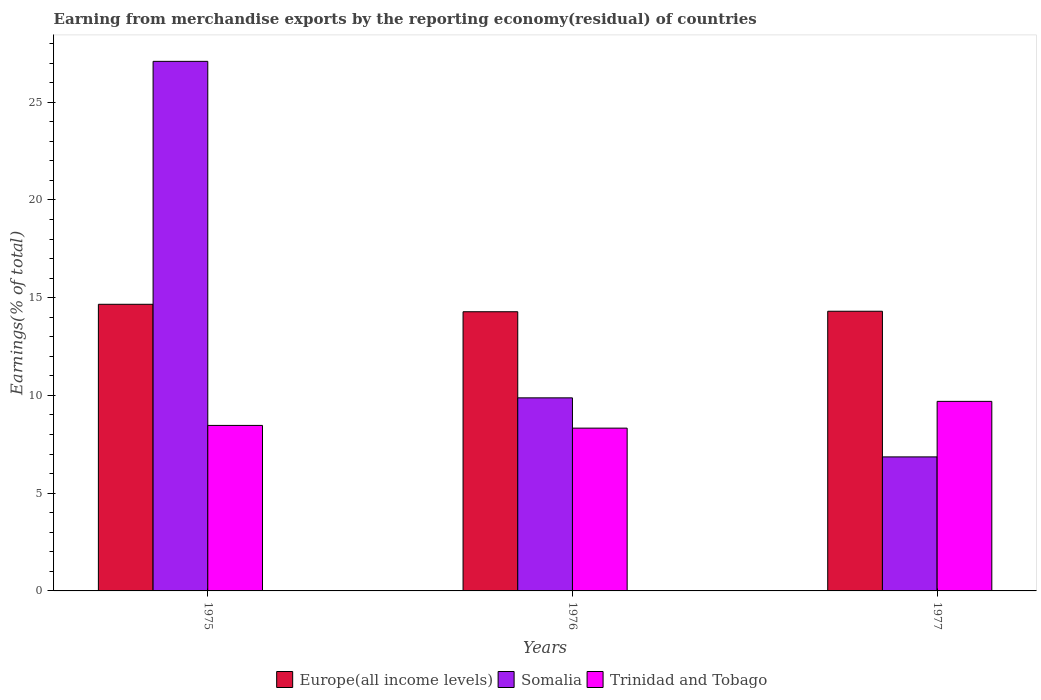How many groups of bars are there?
Provide a short and direct response. 3. Are the number of bars per tick equal to the number of legend labels?
Provide a short and direct response. Yes. Are the number of bars on each tick of the X-axis equal?
Keep it short and to the point. Yes. What is the label of the 2nd group of bars from the left?
Offer a terse response. 1976. What is the percentage of amount earned from merchandise exports in Europe(all income levels) in 1977?
Offer a very short reply. 14.31. Across all years, what is the maximum percentage of amount earned from merchandise exports in Somalia?
Give a very brief answer. 27.09. Across all years, what is the minimum percentage of amount earned from merchandise exports in Somalia?
Make the answer very short. 6.86. In which year was the percentage of amount earned from merchandise exports in Europe(all income levels) maximum?
Make the answer very short. 1975. In which year was the percentage of amount earned from merchandise exports in Trinidad and Tobago minimum?
Provide a short and direct response. 1976. What is the total percentage of amount earned from merchandise exports in Trinidad and Tobago in the graph?
Give a very brief answer. 26.49. What is the difference between the percentage of amount earned from merchandise exports in Somalia in 1975 and that in 1977?
Keep it short and to the point. 20.24. What is the difference between the percentage of amount earned from merchandise exports in Europe(all income levels) in 1977 and the percentage of amount earned from merchandise exports in Trinidad and Tobago in 1976?
Keep it short and to the point. 5.98. What is the average percentage of amount earned from merchandise exports in Trinidad and Tobago per year?
Give a very brief answer. 8.83. In the year 1976, what is the difference between the percentage of amount earned from merchandise exports in Europe(all income levels) and percentage of amount earned from merchandise exports in Somalia?
Give a very brief answer. 4.4. In how many years, is the percentage of amount earned from merchandise exports in Trinidad and Tobago greater than 24 %?
Offer a very short reply. 0. What is the ratio of the percentage of amount earned from merchandise exports in Somalia in 1976 to that in 1977?
Your answer should be very brief. 1.44. Is the percentage of amount earned from merchandise exports in Europe(all income levels) in 1975 less than that in 1976?
Offer a terse response. No. What is the difference between the highest and the second highest percentage of amount earned from merchandise exports in Trinidad and Tobago?
Offer a terse response. 1.23. What is the difference between the highest and the lowest percentage of amount earned from merchandise exports in Somalia?
Give a very brief answer. 20.24. What does the 3rd bar from the left in 1977 represents?
Provide a succinct answer. Trinidad and Tobago. What does the 1st bar from the right in 1975 represents?
Your response must be concise. Trinidad and Tobago. How many bars are there?
Make the answer very short. 9. Are the values on the major ticks of Y-axis written in scientific E-notation?
Your response must be concise. No. How many legend labels are there?
Make the answer very short. 3. How are the legend labels stacked?
Your answer should be very brief. Horizontal. What is the title of the graph?
Give a very brief answer. Earning from merchandise exports by the reporting economy(residual) of countries. What is the label or title of the Y-axis?
Give a very brief answer. Earnings(% of total). What is the Earnings(% of total) of Europe(all income levels) in 1975?
Your answer should be very brief. 14.66. What is the Earnings(% of total) of Somalia in 1975?
Your answer should be compact. 27.09. What is the Earnings(% of total) of Trinidad and Tobago in 1975?
Your answer should be compact. 8.47. What is the Earnings(% of total) of Europe(all income levels) in 1976?
Your response must be concise. 14.28. What is the Earnings(% of total) of Somalia in 1976?
Offer a very short reply. 9.88. What is the Earnings(% of total) in Trinidad and Tobago in 1976?
Keep it short and to the point. 8.33. What is the Earnings(% of total) in Europe(all income levels) in 1977?
Your answer should be very brief. 14.31. What is the Earnings(% of total) in Somalia in 1977?
Your response must be concise. 6.86. What is the Earnings(% of total) of Trinidad and Tobago in 1977?
Offer a terse response. 9.7. Across all years, what is the maximum Earnings(% of total) of Europe(all income levels)?
Ensure brevity in your answer.  14.66. Across all years, what is the maximum Earnings(% of total) in Somalia?
Your answer should be very brief. 27.09. Across all years, what is the maximum Earnings(% of total) in Trinidad and Tobago?
Make the answer very short. 9.7. Across all years, what is the minimum Earnings(% of total) in Europe(all income levels)?
Give a very brief answer. 14.28. Across all years, what is the minimum Earnings(% of total) of Somalia?
Make the answer very short. 6.86. Across all years, what is the minimum Earnings(% of total) in Trinidad and Tobago?
Your answer should be very brief. 8.33. What is the total Earnings(% of total) in Europe(all income levels) in the graph?
Keep it short and to the point. 43.25. What is the total Earnings(% of total) of Somalia in the graph?
Keep it short and to the point. 43.82. What is the total Earnings(% of total) in Trinidad and Tobago in the graph?
Provide a succinct answer. 26.49. What is the difference between the Earnings(% of total) of Europe(all income levels) in 1975 and that in 1976?
Offer a terse response. 0.38. What is the difference between the Earnings(% of total) in Somalia in 1975 and that in 1976?
Keep it short and to the point. 17.21. What is the difference between the Earnings(% of total) in Trinidad and Tobago in 1975 and that in 1976?
Ensure brevity in your answer.  0.14. What is the difference between the Earnings(% of total) of Europe(all income levels) in 1975 and that in 1977?
Your answer should be very brief. 0.36. What is the difference between the Earnings(% of total) in Somalia in 1975 and that in 1977?
Make the answer very short. 20.24. What is the difference between the Earnings(% of total) of Trinidad and Tobago in 1975 and that in 1977?
Your response must be concise. -1.23. What is the difference between the Earnings(% of total) in Europe(all income levels) in 1976 and that in 1977?
Give a very brief answer. -0.03. What is the difference between the Earnings(% of total) of Somalia in 1976 and that in 1977?
Ensure brevity in your answer.  3.02. What is the difference between the Earnings(% of total) in Trinidad and Tobago in 1976 and that in 1977?
Give a very brief answer. -1.37. What is the difference between the Earnings(% of total) of Europe(all income levels) in 1975 and the Earnings(% of total) of Somalia in 1976?
Your response must be concise. 4.79. What is the difference between the Earnings(% of total) in Europe(all income levels) in 1975 and the Earnings(% of total) in Trinidad and Tobago in 1976?
Provide a short and direct response. 6.34. What is the difference between the Earnings(% of total) in Somalia in 1975 and the Earnings(% of total) in Trinidad and Tobago in 1976?
Keep it short and to the point. 18.76. What is the difference between the Earnings(% of total) in Europe(all income levels) in 1975 and the Earnings(% of total) in Somalia in 1977?
Your answer should be compact. 7.81. What is the difference between the Earnings(% of total) of Europe(all income levels) in 1975 and the Earnings(% of total) of Trinidad and Tobago in 1977?
Your answer should be compact. 4.97. What is the difference between the Earnings(% of total) in Somalia in 1975 and the Earnings(% of total) in Trinidad and Tobago in 1977?
Make the answer very short. 17.39. What is the difference between the Earnings(% of total) in Europe(all income levels) in 1976 and the Earnings(% of total) in Somalia in 1977?
Make the answer very short. 7.43. What is the difference between the Earnings(% of total) of Europe(all income levels) in 1976 and the Earnings(% of total) of Trinidad and Tobago in 1977?
Provide a succinct answer. 4.58. What is the difference between the Earnings(% of total) in Somalia in 1976 and the Earnings(% of total) in Trinidad and Tobago in 1977?
Provide a succinct answer. 0.18. What is the average Earnings(% of total) of Europe(all income levels) per year?
Keep it short and to the point. 14.42. What is the average Earnings(% of total) in Somalia per year?
Provide a short and direct response. 14.61. What is the average Earnings(% of total) of Trinidad and Tobago per year?
Offer a terse response. 8.83. In the year 1975, what is the difference between the Earnings(% of total) of Europe(all income levels) and Earnings(% of total) of Somalia?
Offer a terse response. -12.43. In the year 1975, what is the difference between the Earnings(% of total) in Europe(all income levels) and Earnings(% of total) in Trinidad and Tobago?
Your answer should be very brief. 6.2. In the year 1975, what is the difference between the Earnings(% of total) of Somalia and Earnings(% of total) of Trinidad and Tobago?
Offer a very short reply. 18.62. In the year 1976, what is the difference between the Earnings(% of total) in Europe(all income levels) and Earnings(% of total) in Somalia?
Your response must be concise. 4.4. In the year 1976, what is the difference between the Earnings(% of total) in Europe(all income levels) and Earnings(% of total) in Trinidad and Tobago?
Offer a very short reply. 5.95. In the year 1976, what is the difference between the Earnings(% of total) in Somalia and Earnings(% of total) in Trinidad and Tobago?
Your answer should be compact. 1.55. In the year 1977, what is the difference between the Earnings(% of total) in Europe(all income levels) and Earnings(% of total) in Somalia?
Provide a short and direct response. 7.45. In the year 1977, what is the difference between the Earnings(% of total) of Europe(all income levels) and Earnings(% of total) of Trinidad and Tobago?
Your answer should be very brief. 4.61. In the year 1977, what is the difference between the Earnings(% of total) of Somalia and Earnings(% of total) of Trinidad and Tobago?
Offer a terse response. -2.84. What is the ratio of the Earnings(% of total) in Europe(all income levels) in 1975 to that in 1976?
Offer a very short reply. 1.03. What is the ratio of the Earnings(% of total) in Somalia in 1975 to that in 1976?
Your answer should be very brief. 2.74. What is the ratio of the Earnings(% of total) of Trinidad and Tobago in 1975 to that in 1976?
Keep it short and to the point. 1.02. What is the ratio of the Earnings(% of total) of Europe(all income levels) in 1975 to that in 1977?
Provide a succinct answer. 1.02. What is the ratio of the Earnings(% of total) of Somalia in 1975 to that in 1977?
Your response must be concise. 3.95. What is the ratio of the Earnings(% of total) in Trinidad and Tobago in 1975 to that in 1977?
Your response must be concise. 0.87. What is the ratio of the Earnings(% of total) in Europe(all income levels) in 1976 to that in 1977?
Keep it short and to the point. 1. What is the ratio of the Earnings(% of total) in Somalia in 1976 to that in 1977?
Provide a succinct answer. 1.44. What is the ratio of the Earnings(% of total) of Trinidad and Tobago in 1976 to that in 1977?
Offer a very short reply. 0.86. What is the difference between the highest and the second highest Earnings(% of total) of Europe(all income levels)?
Offer a terse response. 0.36. What is the difference between the highest and the second highest Earnings(% of total) in Somalia?
Give a very brief answer. 17.21. What is the difference between the highest and the second highest Earnings(% of total) of Trinidad and Tobago?
Keep it short and to the point. 1.23. What is the difference between the highest and the lowest Earnings(% of total) in Europe(all income levels)?
Make the answer very short. 0.38. What is the difference between the highest and the lowest Earnings(% of total) of Somalia?
Provide a succinct answer. 20.24. What is the difference between the highest and the lowest Earnings(% of total) in Trinidad and Tobago?
Your response must be concise. 1.37. 